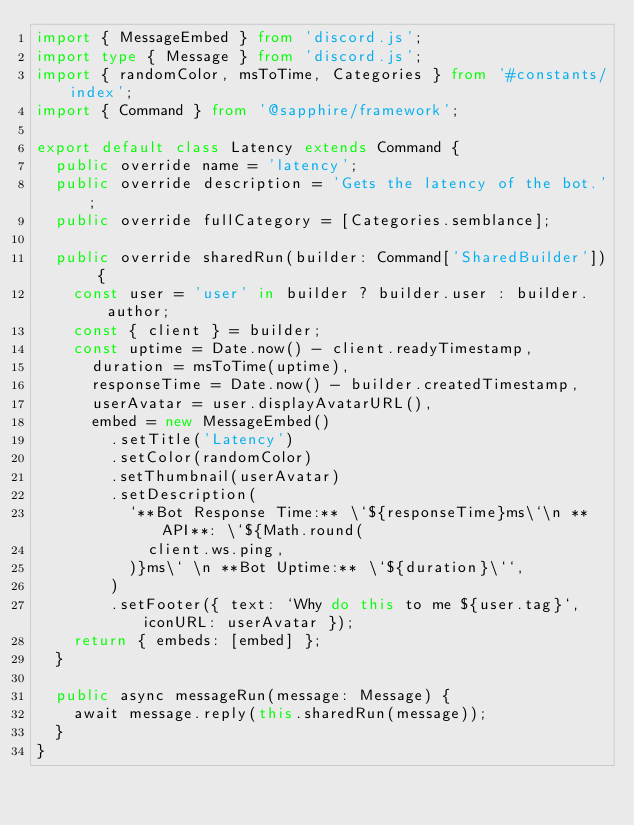Convert code to text. <code><loc_0><loc_0><loc_500><loc_500><_TypeScript_>import { MessageEmbed } from 'discord.js';
import type { Message } from 'discord.js';
import { randomColor, msToTime, Categories } from '#constants/index';
import { Command } from '@sapphire/framework';

export default class Latency extends Command {
  public override name = 'latency';
  public override description = 'Gets the latency of the bot.';
  public override fullCategory = [Categories.semblance];

  public override sharedRun(builder: Command['SharedBuilder']) {
    const user = 'user' in builder ? builder.user : builder.author;
    const { client } = builder;
    const uptime = Date.now() - client.readyTimestamp,
      duration = msToTime(uptime),
      responseTime = Date.now() - builder.createdTimestamp,
      userAvatar = user.displayAvatarURL(),
      embed = new MessageEmbed()
        .setTitle('Latency')
        .setColor(randomColor)
        .setThumbnail(userAvatar)
        .setDescription(
          `**Bot Response Time:** \`${responseTime}ms\`\n **API**: \`${Math.round(
            client.ws.ping,
          )}ms\` \n **Bot Uptime:** \`${duration}\``,
        )
        .setFooter({ text: `Why do this to me ${user.tag}`, iconURL: userAvatar });
    return { embeds: [embed] };
  }

  public async messageRun(message: Message) {
    await message.reply(this.sharedRun(message));
  }
}
</code> 